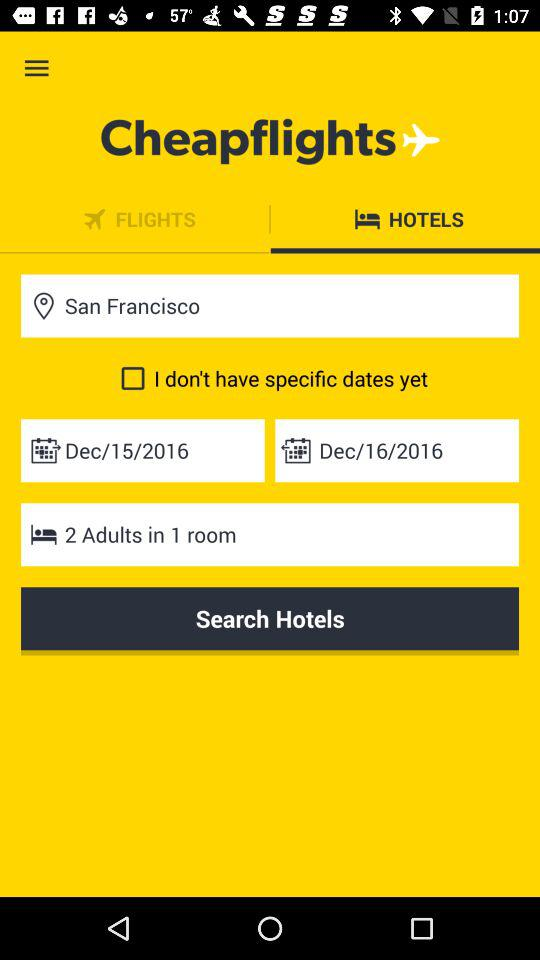What is the check-in date? The check-in date is 15 December, 2016. 